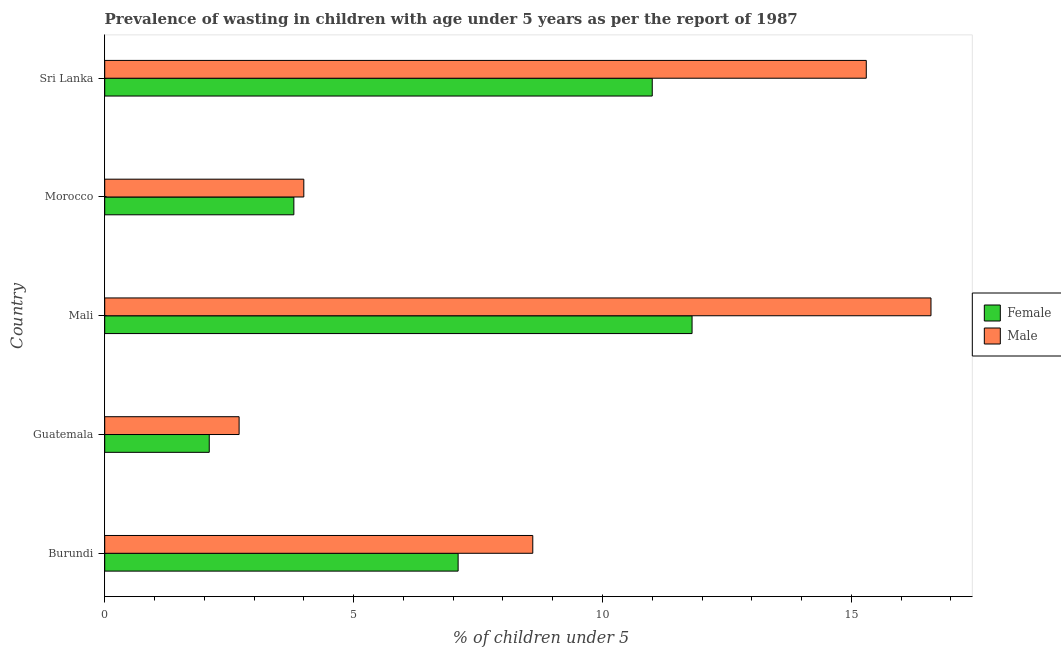How many different coloured bars are there?
Your response must be concise. 2. How many groups of bars are there?
Your response must be concise. 5. Are the number of bars per tick equal to the number of legend labels?
Your answer should be very brief. Yes. Are the number of bars on each tick of the Y-axis equal?
Offer a very short reply. Yes. How many bars are there on the 4th tick from the bottom?
Keep it short and to the point. 2. What is the label of the 1st group of bars from the top?
Your answer should be very brief. Sri Lanka. What is the percentage of undernourished male children in Burundi?
Offer a terse response. 8.6. Across all countries, what is the maximum percentage of undernourished female children?
Your answer should be compact. 11.8. Across all countries, what is the minimum percentage of undernourished female children?
Your answer should be compact. 2.1. In which country was the percentage of undernourished female children maximum?
Provide a short and direct response. Mali. In which country was the percentage of undernourished male children minimum?
Your answer should be very brief. Guatemala. What is the total percentage of undernourished male children in the graph?
Your answer should be very brief. 47.2. What is the difference between the percentage of undernourished female children in Mali and the percentage of undernourished male children in Burundi?
Keep it short and to the point. 3.2. What is the average percentage of undernourished male children per country?
Your answer should be compact. 9.44. What is the ratio of the percentage of undernourished female children in Burundi to that in Mali?
Keep it short and to the point. 0.6. Is the percentage of undernourished female children in Burundi less than that in Mali?
Your response must be concise. Yes. What is the difference between the highest and the second highest percentage of undernourished female children?
Offer a very short reply. 0.8. What does the 1st bar from the top in Mali represents?
Give a very brief answer. Male. Are all the bars in the graph horizontal?
Provide a short and direct response. Yes. How many countries are there in the graph?
Provide a short and direct response. 5. What is the difference between two consecutive major ticks on the X-axis?
Ensure brevity in your answer.  5. Are the values on the major ticks of X-axis written in scientific E-notation?
Offer a terse response. No. Does the graph contain grids?
Offer a terse response. No. Where does the legend appear in the graph?
Provide a succinct answer. Center right. How many legend labels are there?
Give a very brief answer. 2. What is the title of the graph?
Keep it short and to the point. Prevalence of wasting in children with age under 5 years as per the report of 1987. What is the label or title of the X-axis?
Make the answer very short.  % of children under 5. What is the  % of children under 5 of Female in Burundi?
Your answer should be compact. 7.1. What is the  % of children under 5 in Male in Burundi?
Make the answer very short. 8.6. What is the  % of children under 5 of Female in Guatemala?
Give a very brief answer. 2.1. What is the  % of children under 5 in Male in Guatemala?
Provide a succinct answer. 2.7. What is the  % of children under 5 in Female in Mali?
Your response must be concise. 11.8. What is the  % of children under 5 of Male in Mali?
Offer a very short reply. 16.6. What is the  % of children under 5 of Female in Morocco?
Provide a succinct answer. 3.8. What is the  % of children under 5 in Male in Morocco?
Offer a terse response. 4. What is the  % of children under 5 in Male in Sri Lanka?
Give a very brief answer. 15.3. Across all countries, what is the maximum  % of children under 5 in Female?
Ensure brevity in your answer.  11.8. Across all countries, what is the maximum  % of children under 5 of Male?
Make the answer very short. 16.6. Across all countries, what is the minimum  % of children under 5 in Female?
Offer a terse response. 2.1. Across all countries, what is the minimum  % of children under 5 in Male?
Your answer should be compact. 2.7. What is the total  % of children under 5 of Female in the graph?
Provide a short and direct response. 35.8. What is the total  % of children under 5 of Male in the graph?
Give a very brief answer. 47.2. What is the difference between the  % of children under 5 of Female in Burundi and that in Guatemala?
Give a very brief answer. 5. What is the difference between the  % of children under 5 of Female in Burundi and that in Mali?
Provide a short and direct response. -4.7. What is the difference between the  % of children under 5 of Female in Burundi and that in Morocco?
Your answer should be very brief. 3.3. What is the difference between the  % of children under 5 of Male in Burundi and that in Morocco?
Offer a very short reply. 4.6. What is the difference between the  % of children under 5 in Female in Guatemala and that in Mali?
Give a very brief answer. -9.7. What is the difference between the  % of children under 5 of Male in Guatemala and that in Morocco?
Ensure brevity in your answer.  -1.3. What is the difference between the  % of children under 5 in Female in Guatemala and that in Sri Lanka?
Your answer should be very brief. -8.9. What is the difference between the  % of children under 5 of Male in Guatemala and that in Sri Lanka?
Ensure brevity in your answer.  -12.6. What is the difference between the  % of children under 5 of Female in Mali and that in Morocco?
Offer a very short reply. 8. What is the difference between the  % of children under 5 of Female in Mali and that in Sri Lanka?
Give a very brief answer. 0.8. What is the difference between the  % of children under 5 in Male in Mali and that in Sri Lanka?
Your response must be concise. 1.3. What is the difference between the  % of children under 5 in Female in Morocco and that in Sri Lanka?
Keep it short and to the point. -7.2. What is the difference between the  % of children under 5 in Female in Burundi and the  % of children under 5 in Male in Guatemala?
Provide a short and direct response. 4.4. What is the difference between the  % of children under 5 of Female in Burundi and the  % of children under 5 of Male in Mali?
Give a very brief answer. -9.5. What is the difference between the  % of children under 5 in Female in Guatemala and the  % of children under 5 in Male in Mali?
Provide a succinct answer. -14.5. What is the difference between the  % of children under 5 of Female in Guatemala and the  % of children under 5 of Male in Morocco?
Make the answer very short. -1.9. What is the difference between the  % of children under 5 of Female in Guatemala and the  % of children under 5 of Male in Sri Lanka?
Your answer should be very brief. -13.2. What is the difference between the  % of children under 5 in Female in Mali and the  % of children under 5 in Male in Morocco?
Your answer should be compact. 7.8. What is the difference between the  % of children under 5 of Female in Mali and the  % of children under 5 of Male in Sri Lanka?
Ensure brevity in your answer.  -3.5. What is the difference between the  % of children under 5 of Female in Morocco and the  % of children under 5 of Male in Sri Lanka?
Provide a short and direct response. -11.5. What is the average  % of children under 5 in Female per country?
Provide a short and direct response. 7.16. What is the average  % of children under 5 of Male per country?
Give a very brief answer. 9.44. What is the difference between the  % of children under 5 in Female and  % of children under 5 in Male in Morocco?
Provide a short and direct response. -0.2. What is the difference between the  % of children under 5 of Female and  % of children under 5 of Male in Sri Lanka?
Ensure brevity in your answer.  -4.3. What is the ratio of the  % of children under 5 of Female in Burundi to that in Guatemala?
Provide a succinct answer. 3.38. What is the ratio of the  % of children under 5 of Male in Burundi to that in Guatemala?
Your answer should be compact. 3.19. What is the ratio of the  % of children under 5 of Female in Burundi to that in Mali?
Provide a succinct answer. 0.6. What is the ratio of the  % of children under 5 of Male in Burundi to that in Mali?
Your answer should be compact. 0.52. What is the ratio of the  % of children under 5 of Female in Burundi to that in Morocco?
Your answer should be very brief. 1.87. What is the ratio of the  % of children under 5 in Male in Burundi to that in Morocco?
Keep it short and to the point. 2.15. What is the ratio of the  % of children under 5 in Female in Burundi to that in Sri Lanka?
Give a very brief answer. 0.65. What is the ratio of the  % of children under 5 in Male in Burundi to that in Sri Lanka?
Provide a short and direct response. 0.56. What is the ratio of the  % of children under 5 of Female in Guatemala to that in Mali?
Provide a succinct answer. 0.18. What is the ratio of the  % of children under 5 in Male in Guatemala to that in Mali?
Provide a short and direct response. 0.16. What is the ratio of the  % of children under 5 of Female in Guatemala to that in Morocco?
Make the answer very short. 0.55. What is the ratio of the  % of children under 5 of Male in Guatemala to that in Morocco?
Keep it short and to the point. 0.68. What is the ratio of the  % of children under 5 of Female in Guatemala to that in Sri Lanka?
Keep it short and to the point. 0.19. What is the ratio of the  % of children under 5 of Male in Guatemala to that in Sri Lanka?
Your answer should be very brief. 0.18. What is the ratio of the  % of children under 5 in Female in Mali to that in Morocco?
Your response must be concise. 3.11. What is the ratio of the  % of children under 5 of Male in Mali to that in Morocco?
Your response must be concise. 4.15. What is the ratio of the  % of children under 5 of Female in Mali to that in Sri Lanka?
Give a very brief answer. 1.07. What is the ratio of the  % of children under 5 of Male in Mali to that in Sri Lanka?
Keep it short and to the point. 1.08. What is the ratio of the  % of children under 5 in Female in Morocco to that in Sri Lanka?
Give a very brief answer. 0.35. What is the ratio of the  % of children under 5 of Male in Morocco to that in Sri Lanka?
Provide a short and direct response. 0.26. What is the difference between the highest and the second highest  % of children under 5 of Female?
Your answer should be very brief. 0.8. What is the difference between the highest and the second highest  % of children under 5 of Male?
Your response must be concise. 1.3. What is the difference between the highest and the lowest  % of children under 5 of Male?
Your answer should be compact. 13.9. 